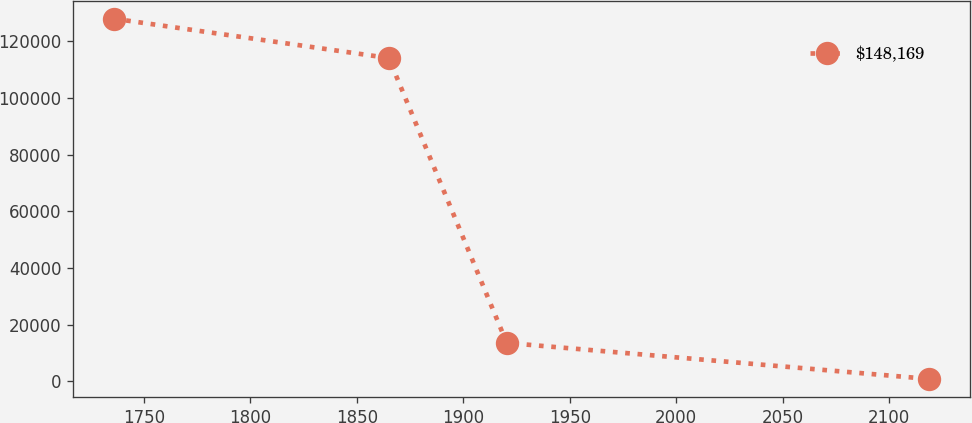<chart> <loc_0><loc_0><loc_500><loc_500><line_chart><ecel><fcel>$148,169<nl><fcel>1736.01<fcel>127981<nl><fcel>1865.05<fcel>114095<nl><fcel>1920.42<fcel>13550<nl><fcel>2118.58<fcel>835.43<nl></chart> 